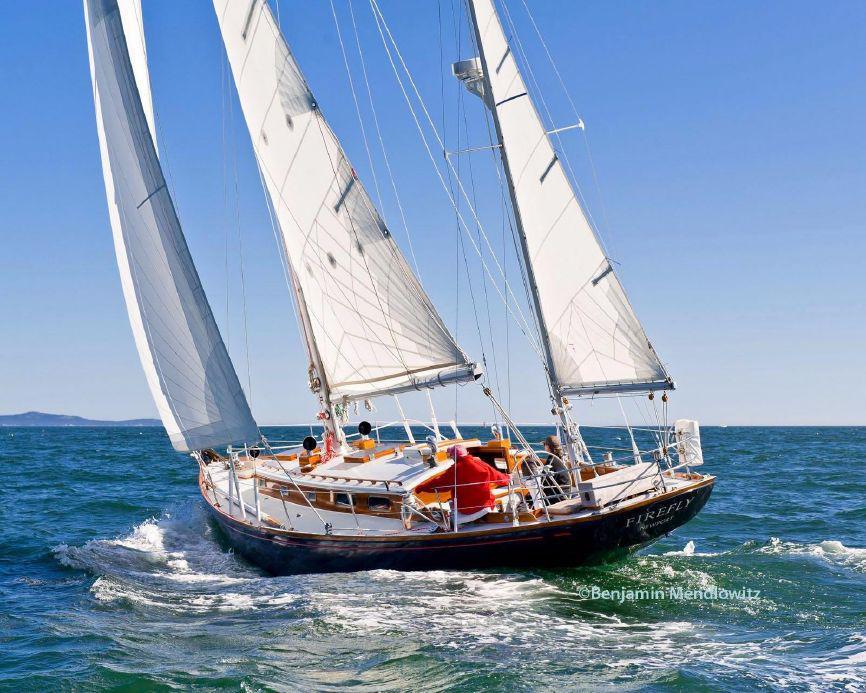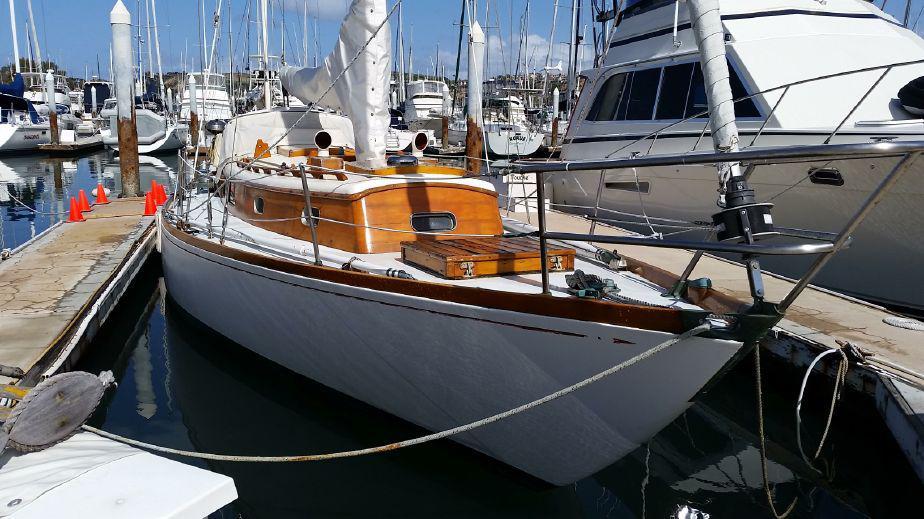The first image is the image on the left, the second image is the image on the right. Considering the images on both sides, is "There are three white sails up on the boat in the image on the left." valid? Answer yes or no. Yes. The first image is the image on the left, the second image is the image on the right. Analyze the images presented: Is the assertion "A sailboat with three unfurled sails in moving through open water with a man wearing a red coat riding at the back." valid? Answer yes or no. Yes. 